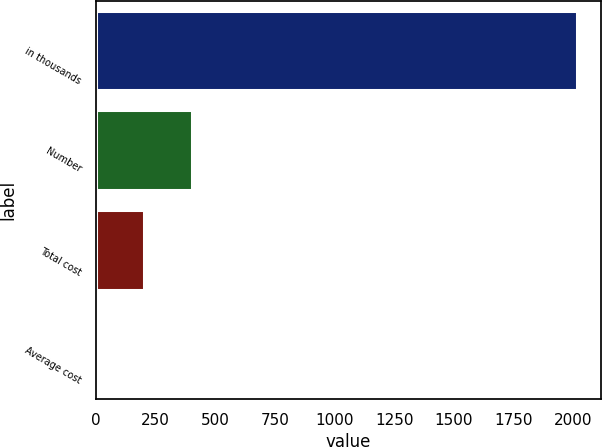Convert chart to OTSL. <chart><loc_0><loc_0><loc_500><loc_500><bar_chart><fcel>in thousands<fcel>Number<fcel>Total cost<fcel>Average cost<nl><fcel>2013<fcel>403.75<fcel>202.59<fcel>1.43<nl></chart> 